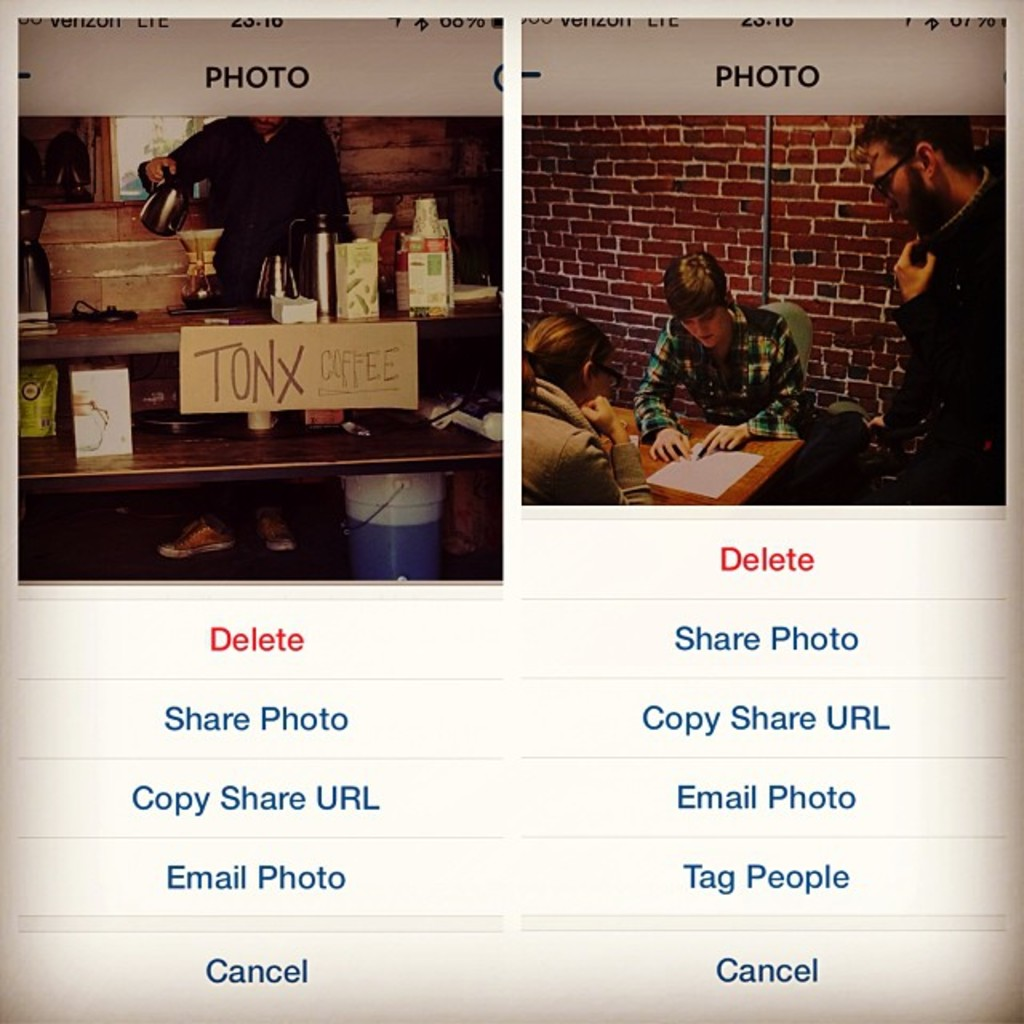Write a detailed description of the given image. The image displays two distinct photographs on a smartphone screen. The photo on the left features a cozy coffee station, complete with a kettle, various containers possibly containing coffee and tea essentials, and a vividly displayed cardboard sign that reads 'TONX COFFEE'. This scene likely takes place in a small, intimate café environment, characterized by its rustic brick wall background and casual setup. The right photo shows three people engaged around a table in what appears to be a deep discussion or collaboration, with one individual actively writing. This suggests a meeting or brainstorming session, possibly in a similar café or informal workspace setting. The smartphone interface visible around the images includes options such as 'Delete', 'Share Photo', and 'Email Photo', suggesting interaction with a photo management or social media app. 